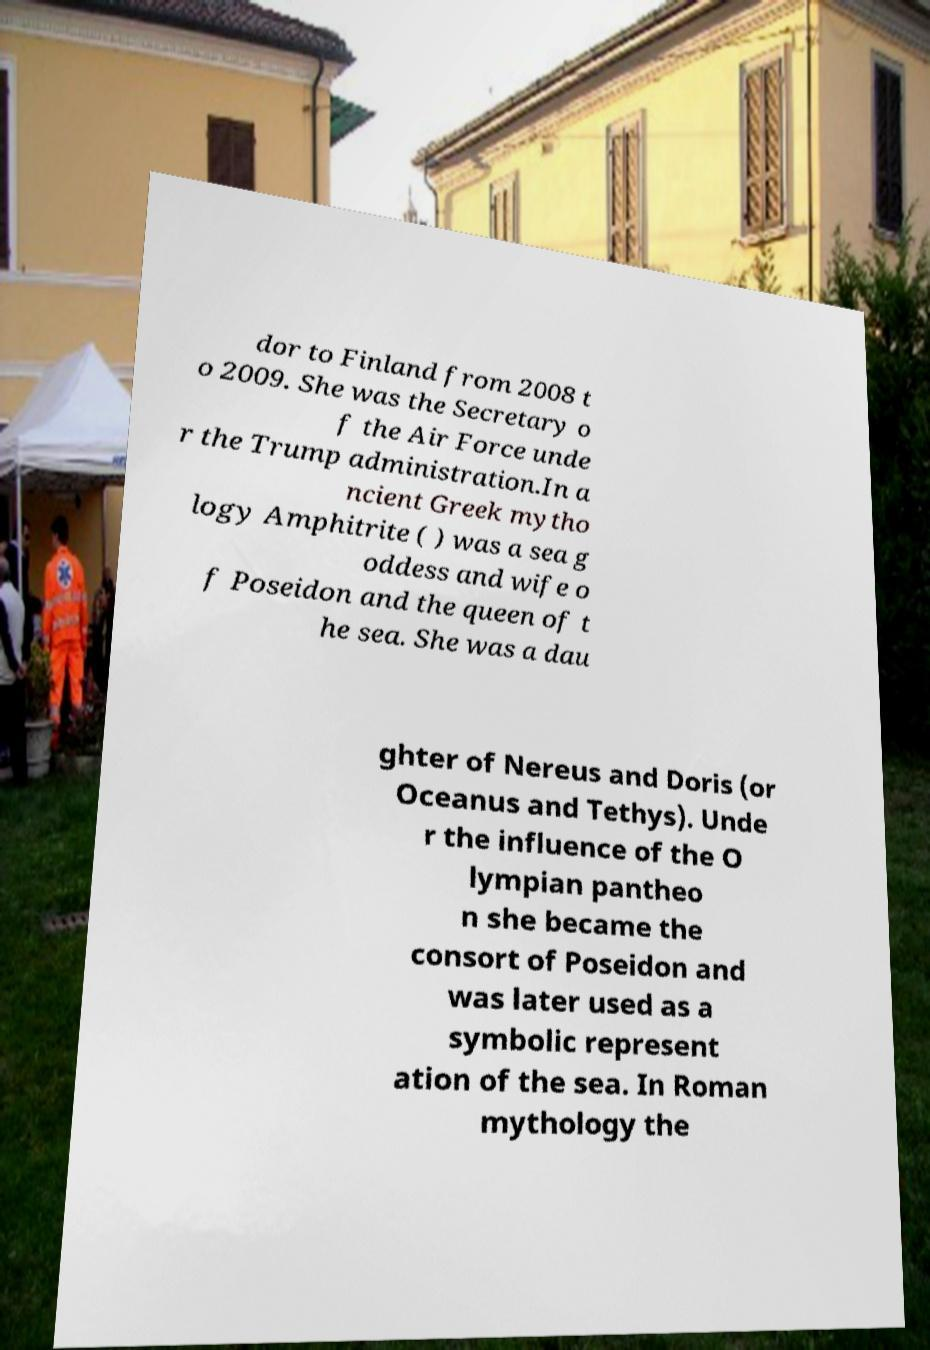What messages or text are displayed in this image? I need them in a readable, typed format. dor to Finland from 2008 t o 2009. She was the Secretary o f the Air Force unde r the Trump administration.In a ncient Greek mytho logy Amphitrite ( ) was a sea g oddess and wife o f Poseidon and the queen of t he sea. She was a dau ghter of Nereus and Doris (or Oceanus and Tethys). Unde r the influence of the O lympian pantheo n she became the consort of Poseidon and was later used as a symbolic represent ation of the sea. In Roman mythology the 